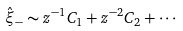Convert formula to latex. <formula><loc_0><loc_0><loc_500><loc_500>\hat { \xi } _ { - } \sim z ^ { - 1 } C _ { 1 } + z ^ { - 2 } C _ { 2 } + \cdots</formula> 